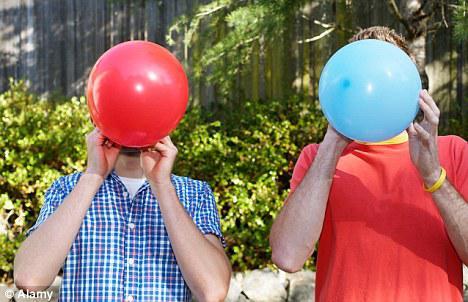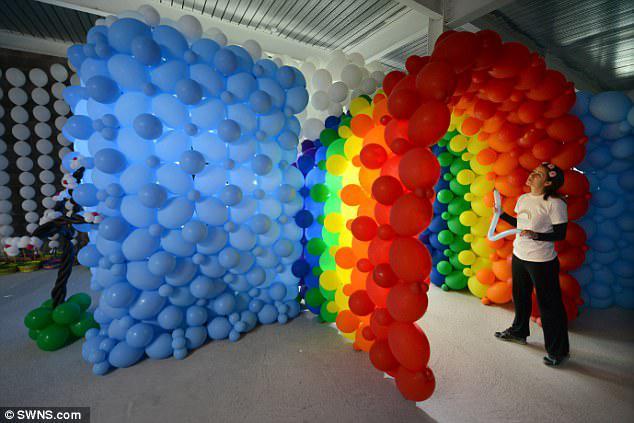The first image is the image on the left, the second image is the image on the right. Considering the images on both sides, is "There is at least one image with a man blowing up a yellow balloon." valid? Answer yes or no. No. The first image is the image on the left, the second image is the image on the right. For the images shown, is this caption "Someone is blowing up a balloon in the right image." true? Answer yes or no. No. 